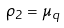Convert formula to latex. <formula><loc_0><loc_0><loc_500><loc_500>\rho _ { 2 } = \mu _ { q }</formula> 